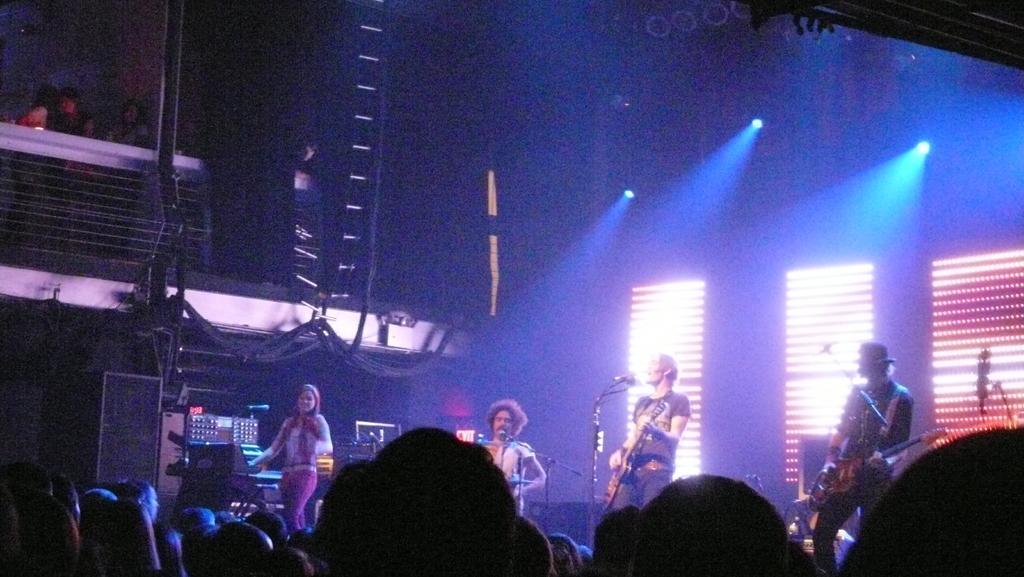Could you give a brief overview of what you see in this image? In this image a musical concert is going on. On the stage few people are playing guitar, drums. In the middle the person is singing. In front of them there are mics. In the background there are lights. 